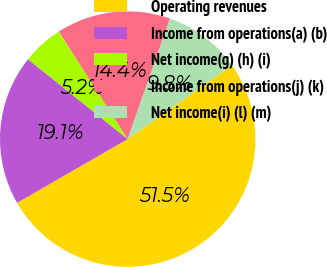Convert chart. <chart><loc_0><loc_0><loc_500><loc_500><pie_chart><fcel>Operating revenues<fcel>Income from operations(a) (b)<fcel>Net income(g) (h) (i)<fcel>Income from operations(j) (k)<fcel>Net income(i) (l) (m)<nl><fcel>51.49%<fcel>19.07%<fcel>5.18%<fcel>14.44%<fcel>9.81%<nl></chart> 